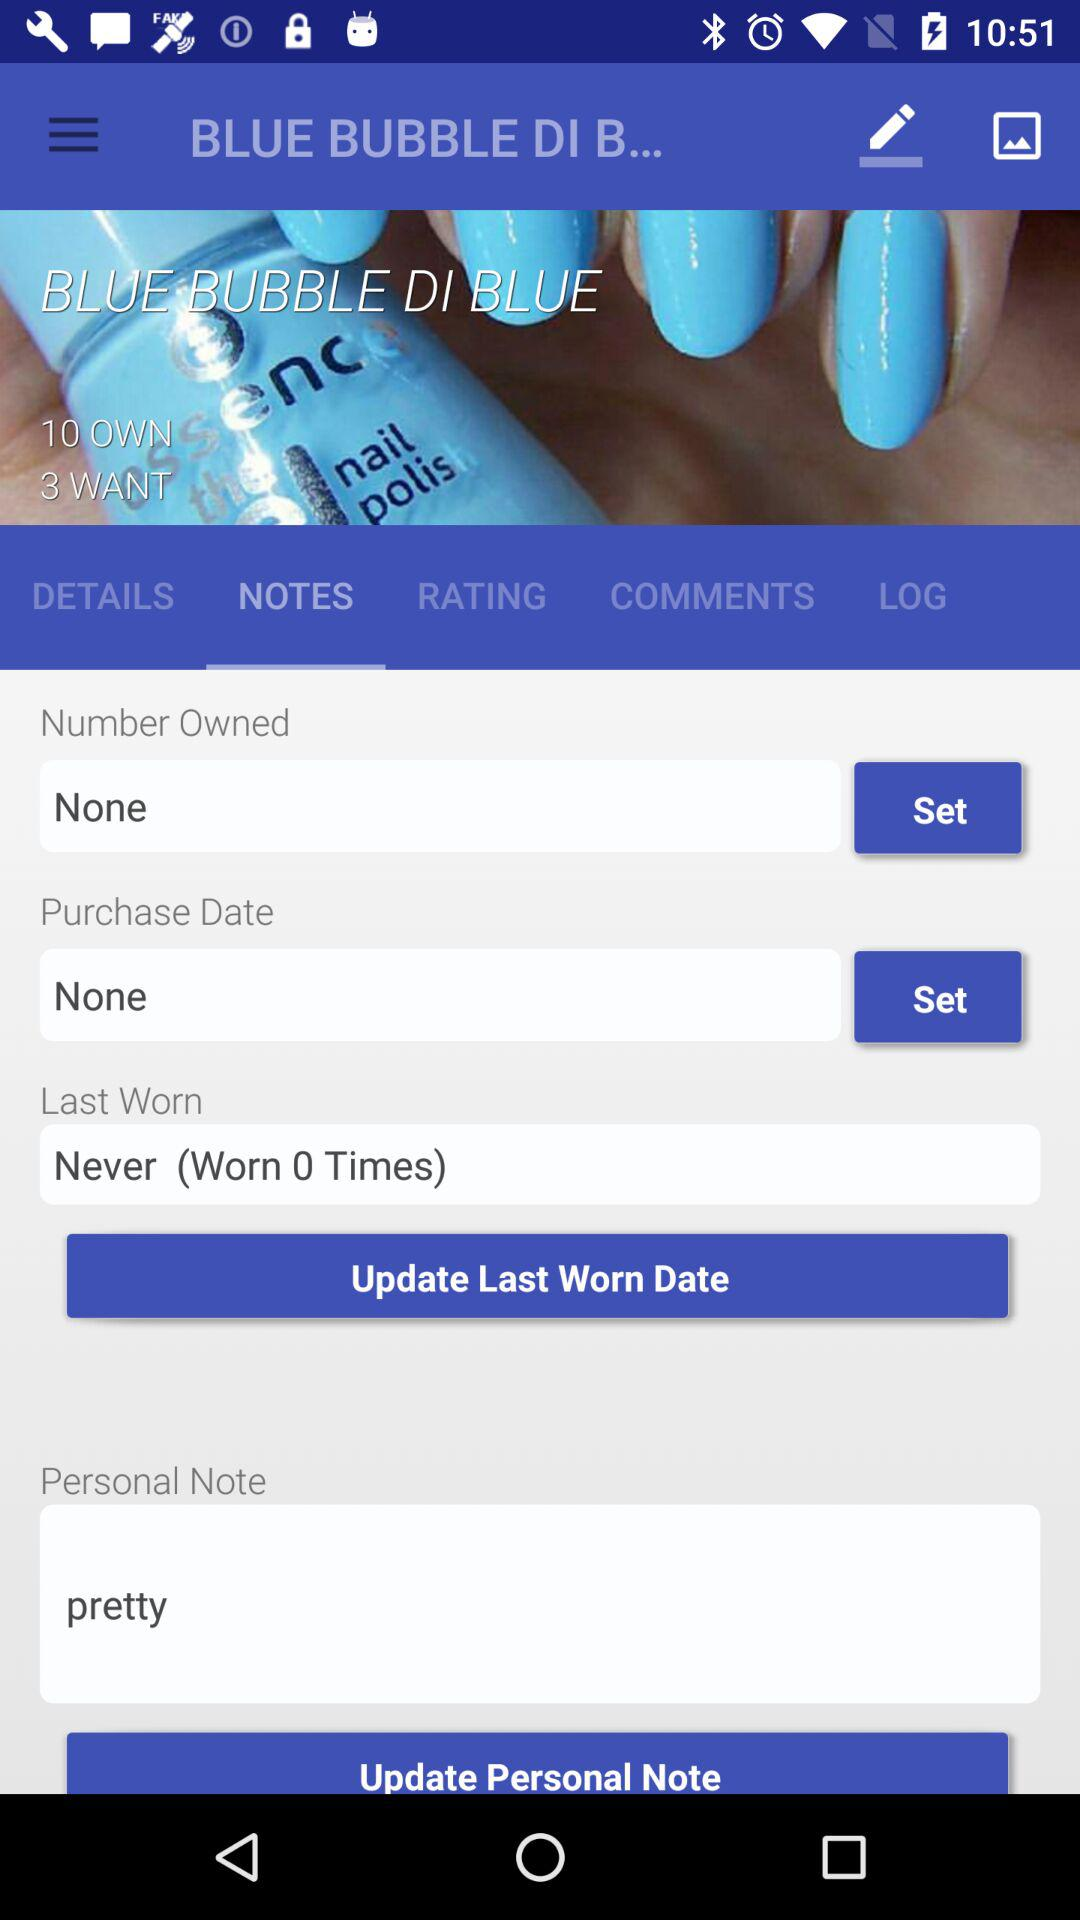Which option is set in the "Number owned" box? The option set in the "Number owned" box is "None". 